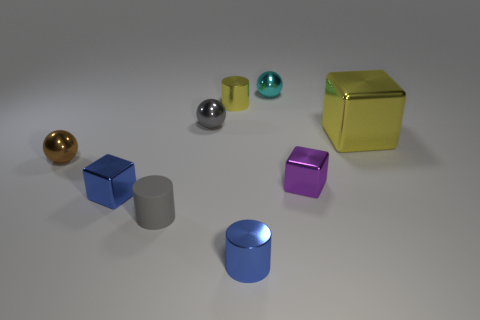Add 1 tiny blue things. How many objects exist? 10 Subtract all cylinders. How many objects are left? 6 Add 4 large cyan spheres. How many large cyan spheres exist? 4 Subtract 0 cyan cylinders. How many objects are left? 9 Subtract all purple metal things. Subtract all tiny blue blocks. How many objects are left? 7 Add 9 small gray cylinders. How many small gray cylinders are left? 10 